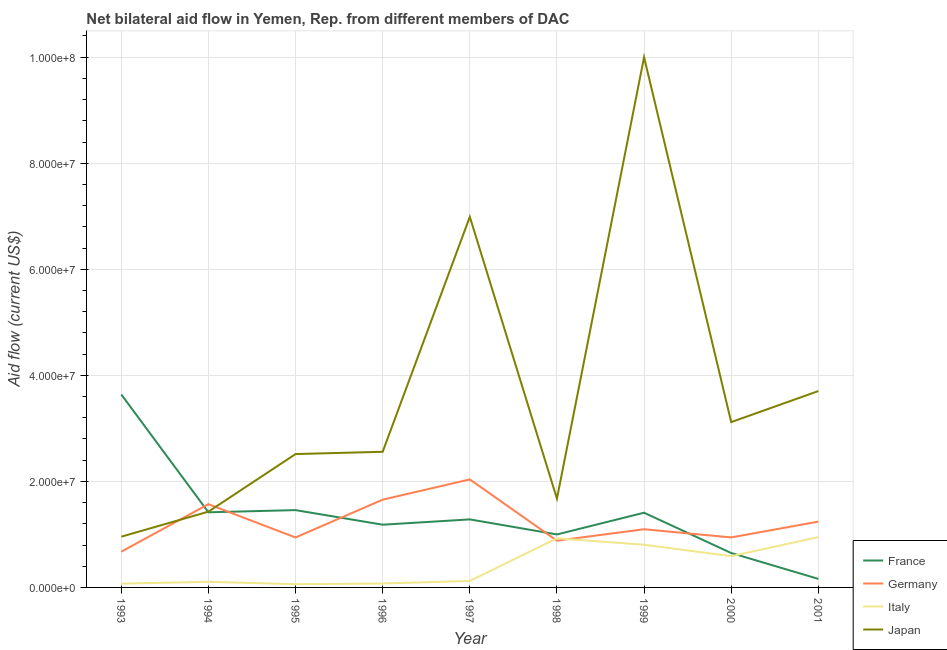Is the number of lines equal to the number of legend labels?
Your answer should be very brief. Yes. What is the amount of aid given by japan in 2000?
Provide a short and direct response. 3.12e+07. Across all years, what is the maximum amount of aid given by italy?
Your answer should be very brief. 9.49e+06. Across all years, what is the minimum amount of aid given by italy?
Provide a short and direct response. 6.10e+05. In which year was the amount of aid given by italy maximum?
Offer a very short reply. 2001. What is the total amount of aid given by germany in the graph?
Your answer should be compact. 1.10e+08. What is the difference between the amount of aid given by france in 1995 and that in 2001?
Your answer should be compact. 1.30e+07. What is the difference between the amount of aid given by germany in 2000 and the amount of aid given by japan in 1996?
Your answer should be compact. -1.62e+07. What is the average amount of aid given by japan per year?
Make the answer very short. 3.66e+07. In the year 1994, what is the difference between the amount of aid given by italy and amount of aid given by france?
Ensure brevity in your answer.  -1.31e+07. In how many years, is the amount of aid given by italy greater than 48000000 US$?
Your answer should be very brief. 0. What is the ratio of the amount of aid given by germany in 1994 to that in 1995?
Keep it short and to the point. 1.67. Is the difference between the amount of aid given by italy in 1997 and 2001 greater than the difference between the amount of aid given by japan in 1997 and 2001?
Your answer should be compact. No. What is the difference between the highest and the second highest amount of aid given by japan?
Your answer should be very brief. 3.01e+07. What is the difference between the highest and the lowest amount of aid given by japan?
Provide a short and direct response. 9.04e+07. Is the sum of the amount of aid given by germany in 1993 and 1997 greater than the maximum amount of aid given by italy across all years?
Ensure brevity in your answer.  Yes. Is it the case that in every year, the sum of the amount of aid given by france and amount of aid given by germany is greater than the sum of amount of aid given by italy and amount of aid given by japan?
Provide a short and direct response. No. Is it the case that in every year, the sum of the amount of aid given by france and amount of aid given by germany is greater than the amount of aid given by italy?
Give a very brief answer. Yes. How many lines are there?
Your answer should be compact. 4. Are the values on the major ticks of Y-axis written in scientific E-notation?
Your answer should be very brief. Yes. Does the graph contain grids?
Give a very brief answer. Yes. Where does the legend appear in the graph?
Your response must be concise. Bottom right. What is the title of the graph?
Keep it short and to the point. Net bilateral aid flow in Yemen, Rep. from different members of DAC. What is the Aid flow (current US$) of France in 1993?
Offer a very short reply. 3.64e+07. What is the Aid flow (current US$) of Germany in 1993?
Give a very brief answer. 6.74e+06. What is the Aid flow (current US$) in Italy in 1993?
Your answer should be compact. 7.10e+05. What is the Aid flow (current US$) of Japan in 1993?
Provide a succinct answer. 9.57e+06. What is the Aid flow (current US$) of France in 1994?
Your response must be concise. 1.42e+07. What is the Aid flow (current US$) in Germany in 1994?
Keep it short and to the point. 1.57e+07. What is the Aid flow (current US$) in Italy in 1994?
Offer a terse response. 1.06e+06. What is the Aid flow (current US$) of Japan in 1994?
Offer a very short reply. 1.43e+07. What is the Aid flow (current US$) of France in 1995?
Provide a short and direct response. 1.46e+07. What is the Aid flow (current US$) of Germany in 1995?
Keep it short and to the point. 9.42e+06. What is the Aid flow (current US$) of Italy in 1995?
Your answer should be very brief. 6.10e+05. What is the Aid flow (current US$) in Japan in 1995?
Offer a very short reply. 2.52e+07. What is the Aid flow (current US$) in France in 1996?
Offer a terse response. 1.18e+07. What is the Aid flow (current US$) in Germany in 1996?
Ensure brevity in your answer.  1.66e+07. What is the Aid flow (current US$) in Italy in 1996?
Give a very brief answer. 7.40e+05. What is the Aid flow (current US$) of Japan in 1996?
Give a very brief answer. 2.56e+07. What is the Aid flow (current US$) of France in 1997?
Give a very brief answer. 1.28e+07. What is the Aid flow (current US$) in Germany in 1997?
Keep it short and to the point. 2.04e+07. What is the Aid flow (current US$) in Italy in 1997?
Ensure brevity in your answer.  1.22e+06. What is the Aid flow (current US$) of Japan in 1997?
Offer a terse response. 6.99e+07. What is the Aid flow (current US$) of France in 1998?
Your answer should be very brief. 9.99e+06. What is the Aid flow (current US$) in Germany in 1998?
Your answer should be very brief. 8.82e+06. What is the Aid flow (current US$) of Italy in 1998?
Give a very brief answer. 9.26e+06. What is the Aid flow (current US$) in Japan in 1998?
Your answer should be very brief. 1.67e+07. What is the Aid flow (current US$) in France in 1999?
Your answer should be compact. 1.41e+07. What is the Aid flow (current US$) in Germany in 1999?
Provide a short and direct response. 1.10e+07. What is the Aid flow (current US$) of Italy in 1999?
Offer a terse response. 8.05e+06. What is the Aid flow (current US$) of Japan in 1999?
Provide a succinct answer. 1.00e+08. What is the Aid flow (current US$) in France in 2000?
Offer a terse response. 6.49e+06. What is the Aid flow (current US$) in Germany in 2000?
Keep it short and to the point. 9.43e+06. What is the Aid flow (current US$) in Italy in 2000?
Your answer should be compact. 5.89e+06. What is the Aid flow (current US$) of Japan in 2000?
Offer a terse response. 3.12e+07. What is the Aid flow (current US$) of France in 2001?
Make the answer very short. 1.61e+06. What is the Aid flow (current US$) of Germany in 2001?
Ensure brevity in your answer.  1.24e+07. What is the Aid flow (current US$) in Italy in 2001?
Ensure brevity in your answer.  9.49e+06. What is the Aid flow (current US$) of Japan in 2001?
Provide a succinct answer. 3.70e+07. Across all years, what is the maximum Aid flow (current US$) of France?
Provide a succinct answer. 3.64e+07. Across all years, what is the maximum Aid flow (current US$) of Germany?
Ensure brevity in your answer.  2.04e+07. Across all years, what is the maximum Aid flow (current US$) in Italy?
Your answer should be very brief. 9.49e+06. Across all years, what is the maximum Aid flow (current US$) in Japan?
Your answer should be compact. 1.00e+08. Across all years, what is the minimum Aid flow (current US$) of France?
Offer a terse response. 1.61e+06. Across all years, what is the minimum Aid flow (current US$) in Germany?
Your response must be concise. 6.74e+06. Across all years, what is the minimum Aid flow (current US$) of Italy?
Provide a succinct answer. 6.10e+05. Across all years, what is the minimum Aid flow (current US$) of Japan?
Offer a very short reply. 9.57e+06. What is the total Aid flow (current US$) of France in the graph?
Make the answer very short. 1.22e+08. What is the total Aid flow (current US$) in Germany in the graph?
Keep it short and to the point. 1.10e+08. What is the total Aid flow (current US$) of Italy in the graph?
Give a very brief answer. 3.70e+07. What is the total Aid flow (current US$) of Japan in the graph?
Keep it short and to the point. 3.29e+08. What is the difference between the Aid flow (current US$) in France in 1993 and that in 1994?
Provide a short and direct response. 2.22e+07. What is the difference between the Aid flow (current US$) of Germany in 1993 and that in 1994?
Make the answer very short. -8.96e+06. What is the difference between the Aid flow (current US$) of Italy in 1993 and that in 1994?
Keep it short and to the point. -3.50e+05. What is the difference between the Aid flow (current US$) in Japan in 1993 and that in 1994?
Provide a short and direct response. -4.72e+06. What is the difference between the Aid flow (current US$) in France in 1993 and that in 1995?
Keep it short and to the point. 2.18e+07. What is the difference between the Aid flow (current US$) in Germany in 1993 and that in 1995?
Your answer should be compact. -2.68e+06. What is the difference between the Aid flow (current US$) of Japan in 1993 and that in 1995?
Provide a succinct answer. -1.56e+07. What is the difference between the Aid flow (current US$) of France in 1993 and that in 1996?
Offer a very short reply. 2.46e+07. What is the difference between the Aid flow (current US$) of Germany in 1993 and that in 1996?
Make the answer very short. -9.81e+06. What is the difference between the Aid flow (current US$) in Japan in 1993 and that in 1996?
Provide a succinct answer. -1.60e+07. What is the difference between the Aid flow (current US$) in France in 1993 and that in 1997?
Your answer should be compact. 2.36e+07. What is the difference between the Aid flow (current US$) in Germany in 1993 and that in 1997?
Offer a very short reply. -1.36e+07. What is the difference between the Aid flow (current US$) in Italy in 1993 and that in 1997?
Keep it short and to the point. -5.10e+05. What is the difference between the Aid flow (current US$) of Japan in 1993 and that in 1997?
Your answer should be compact. -6.03e+07. What is the difference between the Aid flow (current US$) of France in 1993 and that in 1998?
Your response must be concise. 2.64e+07. What is the difference between the Aid flow (current US$) in Germany in 1993 and that in 1998?
Your answer should be compact. -2.08e+06. What is the difference between the Aid flow (current US$) of Italy in 1993 and that in 1998?
Your response must be concise. -8.55e+06. What is the difference between the Aid flow (current US$) in Japan in 1993 and that in 1998?
Your answer should be compact. -7.17e+06. What is the difference between the Aid flow (current US$) in France in 1993 and that in 1999?
Offer a terse response. 2.23e+07. What is the difference between the Aid flow (current US$) in Germany in 1993 and that in 1999?
Your response must be concise. -4.23e+06. What is the difference between the Aid flow (current US$) in Italy in 1993 and that in 1999?
Provide a succinct answer. -7.34e+06. What is the difference between the Aid flow (current US$) in Japan in 1993 and that in 1999?
Make the answer very short. -9.04e+07. What is the difference between the Aid flow (current US$) of France in 1993 and that in 2000?
Offer a very short reply. 2.99e+07. What is the difference between the Aid flow (current US$) of Germany in 1993 and that in 2000?
Give a very brief answer. -2.69e+06. What is the difference between the Aid flow (current US$) in Italy in 1993 and that in 2000?
Offer a terse response. -5.18e+06. What is the difference between the Aid flow (current US$) of Japan in 1993 and that in 2000?
Your response must be concise. -2.16e+07. What is the difference between the Aid flow (current US$) of France in 1993 and that in 2001?
Ensure brevity in your answer.  3.48e+07. What is the difference between the Aid flow (current US$) in Germany in 1993 and that in 2001?
Your answer should be compact. -5.67e+06. What is the difference between the Aid flow (current US$) in Italy in 1993 and that in 2001?
Keep it short and to the point. -8.78e+06. What is the difference between the Aid flow (current US$) in Japan in 1993 and that in 2001?
Your answer should be very brief. -2.75e+07. What is the difference between the Aid flow (current US$) in France in 1994 and that in 1995?
Provide a short and direct response. -4.10e+05. What is the difference between the Aid flow (current US$) in Germany in 1994 and that in 1995?
Your answer should be very brief. 6.28e+06. What is the difference between the Aid flow (current US$) of Italy in 1994 and that in 1995?
Make the answer very short. 4.50e+05. What is the difference between the Aid flow (current US$) of Japan in 1994 and that in 1995?
Keep it short and to the point. -1.09e+07. What is the difference between the Aid flow (current US$) of France in 1994 and that in 1996?
Provide a short and direct response. 2.34e+06. What is the difference between the Aid flow (current US$) of Germany in 1994 and that in 1996?
Offer a terse response. -8.50e+05. What is the difference between the Aid flow (current US$) of Italy in 1994 and that in 1996?
Your response must be concise. 3.20e+05. What is the difference between the Aid flow (current US$) in Japan in 1994 and that in 1996?
Your response must be concise. -1.13e+07. What is the difference between the Aid flow (current US$) of France in 1994 and that in 1997?
Offer a very short reply. 1.34e+06. What is the difference between the Aid flow (current US$) in Germany in 1994 and that in 1997?
Your answer should be compact. -4.67e+06. What is the difference between the Aid flow (current US$) of Italy in 1994 and that in 1997?
Give a very brief answer. -1.60e+05. What is the difference between the Aid flow (current US$) in Japan in 1994 and that in 1997?
Your answer should be very brief. -5.56e+07. What is the difference between the Aid flow (current US$) of France in 1994 and that in 1998?
Your answer should be compact. 4.18e+06. What is the difference between the Aid flow (current US$) of Germany in 1994 and that in 1998?
Offer a terse response. 6.88e+06. What is the difference between the Aid flow (current US$) in Italy in 1994 and that in 1998?
Offer a terse response. -8.20e+06. What is the difference between the Aid flow (current US$) of Japan in 1994 and that in 1998?
Make the answer very short. -2.45e+06. What is the difference between the Aid flow (current US$) of Germany in 1994 and that in 1999?
Keep it short and to the point. 4.73e+06. What is the difference between the Aid flow (current US$) of Italy in 1994 and that in 1999?
Keep it short and to the point. -6.99e+06. What is the difference between the Aid flow (current US$) of Japan in 1994 and that in 1999?
Give a very brief answer. -8.57e+07. What is the difference between the Aid flow (current US$) of France in 1994 and that in 2000?
Your answer should be compact. 7.68e+06. What is the difference between the Aid flow (current US$) in Germany in 1994 and that in 2000?
Provide a short and direct response. 6.27e+06. What is the difference between the Aid flow (current US$) of Italy in 1994 and that in 2000?
Keep it short and to the point. -4.83e+06. What is the difference between the Aid flow (current US$) in Japan in 1994 and that in 2000?
Your response must be concise. -1.69e+07. What is the difference between the Aid flow (current US$) of France in 1994 and that in 2001?
Your response must be concise. 1.26e+07. What is the difference between the Aid flow (current US$) in Germany in 1994 and that in 2001?
Ensure brevity in your answer.  3.29e+06. What is the difference between the Aid flow (current US$) in Italy in 1994 and that in 2001?
Your response must be concise. -8.43e+06. What is the difference between the Aid flow (current US$) of Japan in 1994 and that in 2001?
Your answer should be compact. -2.27e+07. What is the difference between the Aid flow (current US$) of France in 1995 and that in 1996?
Give a very brief answer. 2.75e+06. What is the difference between the Aid flow (current US$) in Germany in 1995 and that in 1996?
Your answer should be compact. -7.13e+06. What is the difference between the Aid flow (current US$) in Italy in 1995 and that in 1996?
Keep it short and to the point. -1.30e+05. What is the difference between the Aid flow (current US$) in Japan in 1995 and that in 1996?
Offer a very short reply. -4.30e+05. What is the difference between the Aid flow (current US$) of France in 1995 and that in 1997?
Offer a very short reply. 1.75e+06. What is the difference between the Aid flow (current US$) of Germany in 1995 and that in 1997?
Your response must be concise. -1.10e+07. What is the difference between the Aid flow (current US$) in Italy in 1995 and that in 1997?
Provide a short and direct response. -6.10e+05. What is the difference between the Aid flow (current US$) of Japan in 1995 and that in 1997?
Give a very brief answer. -4.47e+07. What is the difference between the Aid flow (current US$) of France in 1995 and that in 1998?
Provide a short and direct response. 4.59e+06. What is the difference between the Aid flow (current US$) of Germany in 1995 and that in 1998?
Provide a short and direct response. 6.00e+05. What is the difference between the Aid flow (current US$) of Italy in 1995 and that in 1998?
Make the answer very short. -8.65e+06. What is the difference between the Aid flow (current US$) in Japan in 1995 and that in 1998?
Offer a terse response. 8.41e+06. What is the difference between the Aid flow (current US$) in Germany in 1995 and that in 1999?
Give a very brief answer. -1.55e+06. What is the difference between the Aid flow (current US$) in Italy in 1995 and that in 1999?
Your answer should be very brief. -7.44e+06. What is the difference between the Aid flow (current US$) of Japan in 1995 and that in 1999?
Your response must be concise. -7.48e+07. What is the difference between the Aid flow (current US$) in France in 1995 and that in 2000?
Offer a terse response. 8.09e+06. What is the difference between the Aid flow (current US$) in Italy in 1995 and that in 2000?
Keep it short and to the point. -5.28e+06. What is the difference between the Aid flow (current US$) of Japan in 1995 and that in 2000?
Keep it short and to the point. -6.03e+06. What is the difference between the Aid flow (current US$) in France in 1995 and that in 2001?
Your answer should be very brief. 1.30e+07. What is the difference between the Aid flow (current US$) of Germany in 1995 and that in 2001?
Give a very brief answer. -2.99e+06. What is the difference between the Aid flow (current US$) in Italy in 1995 and that in 2001?
Offer a very short reply. -8.88e+06. What is the difference between the Aid flow (current US$) of Japan in 1995 and that in 2001?
Provide a succinct answer. -1.19e+07. What is the difference between the Aid flow (current US$) in Germany in 1996 and that in 1997?
Your response must be concise. -3.82e+06. What is the difference between the Aid flow (current US$) in Italy in 1996 and that in 1997?
Provide a short and direct response. -4.80e+05. What is the difference between the Aid flow (current US$) of Japan in 1996 and that in 1997?
Keep it short and to the point. -4.43e+07. What is the difference between the Aid flow (current US$) in France in 1996 and that in 1998?
Your response must be concise. 1.84e+06. What is the difference between the Aid flow (current US$) of Germany in 1996 and that in 1998?
Make the answer very short. 7.73e+06. What is the difference between the Aid flow (current US$) in Italy in 1996 and that in 1998?
Your response must be concise. -8.52e+06. What is the difference between the Aid flow (current US$) of Japan in 1996 and that in 1998?
Give a very brief answer. 8.84e+06. What is the difference between the Aid flow (current US$) in France in 1996 and that in 1999?
Offer a terse response. -2.26e+06. What is the difference between the Aid flow (current US$) in Germany in 1996 and that in 1999?
Make the answer very short. 5.58e+06. What is the difference between the Aid flow (current US$) in Italy in 1996 and that in 1999?
Provide a short and direct response. -7.31e+06. What is the difference between the Aid flow (current US$) of Japan in 1996 and that in 1999?
Provide a succinct answer. -7.44e+07. What is the difference between the Aid flow (current US$) of France in 1996 and that in 2000?
Offer a very short reply. 5.34e+06. What is the difference between the Aid flow (current US$) in Germany in 1996 and that in 2000?
Make the answer very short. 7.12e+06. What is the difference between the Aid flow (current US$) of Italy in 1996 and that in 2000?
Your answer should be compact. -5.15e+06. What is the difference between the Aid flow (current US$) in Japan in 1996 and that in 2000?
Your answer should be very brief. -5.60e+06. What is the difference between the Aid flow (current US$) of France in 1996 and that in 2001?
Provide a short and direct response. 1.02e+07. What is the difference between the Aid flow (current US$) of Germany in 1996 and that in 2001?
Ensure brevity in your answer.  4.14e+06. What is the difference between the Aid flow (current US$) of Italy in 1996 and that in 2001?
Provide a succinct answer. -8.75e+06. What is the difference between the Aid flow (current US$) in Japan in 1996 and that in 2001?
Ensure brevity in your answer.  -1.14e+07. What is the difference between the Aid flow (current US$) in France in 1997 and that in 1998?
Keep it short and to the point. 2.84e+06. What is the difference between the Aid flow (current US$) in Germany in 1997 and that in 1998?
Provide a short and direct response. 1.16e+07. What is the difference between the Aid flow (current US$) of Italy in 1997 and that in 1998?
Offer a very short reply. -8.04e+06. What is the difference between the Aid flow (current US$) of Japan in 1997 and that in 1998?
Make the answer very short. 5.32e+07. What is the difference between the Aid flow (current US$) in France in 1997 and that in 1999?
Keep it short and to the point. -1.26e+06. What is the difference between the Aid flow (current US$) of Germany in 1997 and that in 1999?
Your answer should be compact. 9.40e+06. What is the difference between the Aid flow (current US$) in Italy in 1997 and that in 1999?
Your response must be concise. -6.83e+06. What is the difference between the Aid flow (current US$) in Japan in 1997 and that in 1999?
Provide a succinct answer. -3.01e+07. What is the difference between the Aid flow (current US$) in France in 1997 and that in 2000?
Keep it short and to the point. 6.34e+06. What is the difference between the Aid flow (current US$) in Germany in 1997 and that in 2000?
Your response must be concise. 1.09e+07. What is the difference between the Aid flow (current US$) in Italy in 1997 and that in 2000?
Ensure brevity in your answer.  -4.67e+06. What is the difference between the Aid flow (current US$) of Japan in 1997 and that in 2000?
Your answer should be compact. 3.87e+07. What is the difference between the Aid flow (current US$) in France in 1997 and that in 2001?
Offer a terse response. 1.12e+07. What is the difference between the Aid flow (current US$) of Germany in 1997 and that in 2001?
Provide a succinct answer. 7.96e+06. What is the difference between the Aid flow (current US$) of Italy in 1997 and that in 2001?
Your answer should be very brief. -8.27e+06. What is the difference between the Aid flow (current US$) of Japan in 1997 and that in 2001?
Provide a short and direct response. 3.29e+07. What is the difference between the Aid flow (current US$) in France in 1998 and that in 1999?
Keep it short and to the point. -4.10e+06. What is the difference between the Aid flow (current US$) of Germany in 1998 and that in 1999?
Offer a terse response. -2.15e+06. What is the difference between the Aid flow (current US$) in Italy in 1998 and that in 1999?
Give a very brief answer. 1.21e+06. What is the difference between the Aid flow (current US$) in Japan in 1998 and that in 1999?
Your answer should be compact. -8.33e+07. What is the difference between the Aid flow (current US$) in France in 1998 and that in 2000?
Provide a short and direct response. 3.50e+06. What is the difference between the Aid flow (current US$) in Germany in 1998 and that in 2000?
Your answer should be very brief. -6.10e+05. What is the difference between the Aid flow (current US$) in Italy in 1998 and that in 2000?
Offer a very short reply. 3.37e+06. What is the difference between the Aid flow (current US$) in Japan in 1998 and that in 2000?
Ensure brevity in your answer.  -1.44e+07. What is the difference between the Aid flow (current US$) of France in 1998 and that in 2001?
Give a very brief answer. 8.38e+06. What is the difference between the Aid flow (current US$) in Germany in 1998 and that in 2001?
Give a very brief answer. -3.59e+06. What is the difference between the Aid flow (current US$) of Japan in 1998 and that in 2001?
Offer a terse response. -2.03e+07. What is the difference between the Aid flow (current US$) of France in 1999 and that in 2000?
Your answer should be very brief. 7.60e+06. What is the difference between the Aid flow (current US$) in Germany in 1999 and that in 2000?
Offer a very short reply. 1.54e+06. What is the difference between the Aid flow (current US$) of Italy in 1999 and that in 2000?
Your response must be concise. 2.16e+06. What is the difference between the Aid flow (current US$) of Japan in 1999 and that in 2000?
Give a very brief answer. 6.88e+07. What is the difference between the Aid flow (current US$) of France in 1999 and that in 2001?
Offer a very short reply. 1.25e+07. What is the difference between the Aid flow (current US$) of Germany in 1999 and that in 2001?
Your answer should be very brief. -1.44e+06. What is the difference between the Aid flow (current US$) in Italy in 1999 and that in 2001?
Keep it short and to the point. -1.44e+06. What is the difference between the Aid flow (current US$) of Japan in 1999 and that in 2001?
Keep it short and to the point. 6.30e+07. What is the difference between the Aid flow (current US$) of France in 2000 and that in 2001?
Provide a succinct answer. 4.88e+06. What is the difference between the Aid flow (current US$) of Germany in 2000 and that in 2001?
Ensure brevity in your answer.  -2.98e+06. What is the difference between the Aid flow (current US$) of Italy in 2000 and that in 2001?
Provide a succinct answer. -3.60e+06. What is the difference between the Aid flow (current US$) in Japan in 2000 and that in 2001?
Your answer should be very brief. -5.85e+06. What is the difference between the Aid flow (current US$) in France in 1993 and the Aid flow (current US$) in Germany in 1994?
Your answer should be very brief. 2.07e+07. What is the difference between the Aid flow (current US$) in France in 1993 and the Aid flow (current US$) in Italy in 1994?
Make the answer very short. 3.53e+07. What is the difference between the Aid flow (current US$) in France in 1993 and the Aid flow (current US$) in Japan in 1994?
Provide a short and direct response. 2.21e+07. What is the difference between the Aid flow (current US$) of Germany in 1993 and the Aid flow (current US$) of Italy in 1994?
Make the answer very short. 5.68e+06. What is the difference between the Aid flow (current US$) of Germany in 1993 and the Aid flow (current US$) of Japan in 1994?
Give a very brief answer. -7.55e+06. What is the difference between the Aid flow (current US$) of Italy in 1993 and the Aid flow (current US$) of Japan in 1994?
Your response must be concise. -1.36e+07. What is the difference between the Aid flow (current US$) of France in 1993 and the Aid flow (current US$) of Germany in 1995?
Your answer should be compact. 2.70e+07. What is the difference between the Aid flow (current US$) of France in 1993 and the Aid flow (current US$) of Italy in 1995?
Your answer should be compact. 3.58e+07. What is the difference between the Aid flow (current US$) of France in 1993 and the Aid flow (current US$) of Japan in 1995?
Your answer should be very brief. 1.12e+07. What is the difference between the Aid flow (current US$) of Germany in 1993 and the Aid flow (current US$) of Italy in 1995?
Offer a very short reply. 6.13e+06. What is the difference between the Aid flow (current US$) of Germany in 1993 and the Aid flow (current US$) of Japan in 1995?
Your answer should be very brief. -1.84e+07. What is the difference between the Aid flow (current US$) in Italy in 1993 and the Aid flow (current US$) in Japan in 1995?
Your response must be concise. -2.44e+07. What is the difference between the Aid flow (current US$) in France in 1993 and the Aid flow (current US$) in Germany in 1996?
Ensure brevity in your answer.  1.98e+07. What is the difference between the Aid flow (current US$) of France in 1993 and the Aid flow (current US$) of Italy in 1996?
Your answer should be very brief. 3.56e+07. What is the difference between the Aid flow (current US$) of France in 1993 and the Aid flow (current US$) of Japan in 1996?
Your answer should be very brief. 1.08e+07. What is the difference between the Aid flow (current US$) in Germany in 1993 and the Aid flow (current US$) in Italy in 1996?
Provide a short and direct response. 6.00e+06. What is the difference between the Aid flow (current US$) of Germany in 1993 and the Aid flow (current US$) of Japan in 1996?
Provide a short and direct response. -1.88e+07. What is the difference between the Aid flow (current US$) in Italy in 1993 and the Aid flow (current US$) in Japan in 1996?
Provide a short and direct response. -2.49e+07. What is the difference between the Aid flow (current US$) in France in 1993 and the Aid flow (current US$) in Germany in 1997?
Keep it short and to the point. 1.60e+07. What is the difference between the Aid flow (current US$) of France in 1993 and the Aid flow (current US$) of Italy in 1997?
Offer a terse response. 3.52e+07. What is the difference between the Aid flow (current US$) of France in 1993 and the Aid flow (current US$) of Japan in 1997?
Offer a terse response. -3.35e+07. What is the difference between the Aid flow (current US$) in Germany in 1993 and the Aid flow (current US$) in Italy in 1997?
Keep it short and to the point. 5.52e+06. What is the difference between the Aid flow (current US$) of Germany in 1993 and the Aid flow (current US$) of Japan in 1997?
Ensure brevity in your answer.  -6.32e+07. What is the difference between the Aid flow (current US$) in Italy in 1993 and the Aid flow (current US$) in Japan in 1997?
Give a very brief answer. -6.92e+07. What is the difference between the Aid flow (current US$) of France in 1993 and the Aid flow (current US$) of Germany in 1998?
Offer a very short reply. 2.76e+07. What is the difference between the Aid flow (current US$) of France in 1993 and the Aid flow (current US$) of Italy in 1998?
Your response must be concise. 2.71e+07. What is the difference between the Aid flow (current US$) in France in 1993 and the Aid flow (current US$) in Japan in 1998?
Provide a succinct answer. 1.96e+07. What is the difference between the Aid flow (current US$) in Germany in 1993 and the Aid flow (current US$) in Italy in 1998?
Provide a succinct answer. -2.52e+06. What is the difference between the Aid flow (current US$) in Germany in 1993 and the Aid flow (current US$) in Japan in 1998?
Make the answer very short. -1.00e+07. What is the difference between the Aid flow (current US$) in Italy in 1993 and the Aid flow (current US$) in Japan in 1998?
Provide a short and direct response. -1.60e+07. What is the difference between the Aid flow (current US$) of France in 1993 and the Aid flow (current US$) of Germany in 1999?
Offer a very short reply. 2.54e+07. What is the difference between the Aid flow (current US$) in France in 1993 and the Aid flow (current US$) in Italy in 1999?
Give a very brief answer. 2.83e+07. What is the difference between the Aid flow (current US$) of France in 1993 and the Aid flow (current US$) of Japan in 1999?
Provide a short and direct response. -6.36e+07. What is the difference between the Aid flow (current US$) in Germany in 1993 and the Aid flow (current US$) in Italy in 1999?
Make the answer very short. -1.31e+06. What is the difference between the Aid flow (current US$) of Germany in 1993 and the Aid flow (current US$) of Japan in 1999?
Offer a terse response. -9.33e+07. What is the difference between the Aid flow (current US$) of Italy in 1993 and the Aid flow (current US$) of Japan in 1999?
Your answer should be very brief. -9.93e+07. What is the difference between the Aid flow (current US$) in France in 1993 and the Aid flow (current US$) in Germany in 2000?
Offer a terse response. 2.70e+07. What is the difference between the Aid flow (current US$) of France in 1993 and the Aid flow (current US$) of Italy in 2000?
Your answer should be very brief. 3.05e+07. What is the difference between the Aid flow (current US$) in France in 1993 and the Aid flow (current US$) in Japan in 2000?
Ensure brevity in your answer.  5.21e+06. What is the difference between the Aid flow (current US$) of Germany in 1993 and the Aid flow (current US$) of Italy in 2000?
Your answer should be compact. 8.50e+05. What is the difference between the Aid flow (current US$) of Germany in 1993 and the Aid flow (current US$) of Japan in 2000?
Provide a succinct answer. -2.44e+07. What is the difference between the Aid flow (current US$) in Italy in 1993 and the Aid flow (current US$) in Japan in 2000?
Provide a short and direct response. -3.05e+07. What is the difference between the Aid flow (current US$) of France in 1993 and the Aid flow (current US$) of Germany in 2001?
Give a very brief answer. 2.40e+07. What is the difference between the Aid flow (current US$) of France in 1993 and the Aid flow (current US$) of Italy in 2001?
Provide a short and direct response. 2.69e+07. What is the difference between the Aid flow (current US$) of France in 1993 and the Aid flow (current US$) of Japan in 2001?
Your response must be concise. -6.40e+05. What is the difference between the Aid flow (current US$) in Germany in 1993 and the Aid flow (current US$) in Italy in 2001?
Your answer should be compact. -2.75e+06. What is the difference between the Aid flow (current US$) of Germany in 1993 and the Aid flow (current US$) of Japan in 2001?
Provide a succinct answer. -3.03e+07. What is the difference between the Aid flow (current US$) of Italy in 1993 and the Aid flow (current US$) of Japan in 2001?
Provide a succinct answer. -3.63e+07. What is the difference between the Aid flow (current US$) in France in 1994 and the Aid flow (current US$) in Germany in 1995?
Your response must be concise. 4.75e+06. What is the difference between the Aid flow (current US$) in France in 1994 and the Aid flow (current US$) in Italy in 1995?
Provide a succinct answer. 1.36e+07. What is the difference between the Aid flow (current US$) in France in 1994 and the Aid flow (current US$) in Japan in 1995?
Make the answer very short. -1.10e+07. What is the difference between the Aid flow (current US$) in Germany in 1994 and the Aid flow (current US$) in Italy in 1995?
Your answer should be compact. 1.51e+07. What is the difference between the Aid flow (current US$) of Germany in 1994 and the Aid flow (current US$) of Japan in 1995?
Provide a succinct answer. -9.45e+06. What is the difference between the Aid flow (current US$) of Italy in 1994 and the Aid flow (current US$) of Japan in 1995?
Give a very brief answer. -2.41e+07. What is the difference between the Aid flow (current US$) of France in 1994 and the Aid flow (current US$) of Germany in 1996?
Provide a succinct answer. -2.38e+06. What is the difference between the Aid flow (current US$) in France in 1994 and the Aid flow (current US$) in Italy in 1996?
Keep it short and to the point. 1.34e+07. What is the difference between the Aid flow (current US$) in France in 1994 and the Aid flow (current US$) in Japan in 1996?
Offer a very short reply. -1.14e+07. What is the difference between the Aid flow (current US$) of Germany in 1994 and the Aid flow (current US$) of Italy in 1996?
Make the answer very short. 1.50e+07. What is the difference between the Aid flow (current US$) of Germany in 1994 and the Aid flow (current US$) of Japan in 1996?
Offer a very short reply. -9.88e+06. What is the difference between the Aid flow (current US$) in Italy in 1994 and the Aid flow (current US$) in Japan in 1996?
Offer a very short reply. -2.45e+07. What is the difference between the Aid flow (current US$) of France in 1994 and the Aid flow (current US$) of Germany in 1997?
Offer a terse response. -6.20e+06. What is the difference between the Aid flow (current US$) of France in 1994 and the Aid flow (current US$) of Italy in 1997?
Your answer should be very brief. 1.30e+07. What is the difference between the Aid flow (current US$) of France in 1994 and the Aid flow (current US$) of Japan in 1997?
Give a very brief answer. -5.57e+07. What is the difference between the Aid flow (current US$) in Germany in 1994 and the Aid flow (current US$) in Italy in 1997?
Your response must be concise. 1.45e+07. What is the difference between the Aid flow (current US$) in Germany in 1994 and the Aid flow (current US$) in Japan in 1997?
Offer a very short reply. -5.42e+07. What is the difference between the Aid flow (current US$) in Italy in 1994 and the Aid flow (current US$) in Japan in 1997?
Provide a short and direct response. -6.88e+07. What is the difference between the Aid flow (current US$) in France in 1994 and the Aid flow (current US$) in Germany in 1998?
Your answer should be compact. 5.35e+06. What is the difference between the Aid flow (current US$) in France in 1994 and the Aid flow (current US$) in Italy in 1998?
Ensure brevity in your answer.  4.91e+06. What is the difference between the Aid flow (current US$) of France in 1994 and the Aid flow (current US$) of Japan in 1998?
Your answer should be very brief. -2.57e+06. What is the difference between the Aid flow (current US$) of Germany in 1994 and the Aid flow (current US$) of Italy in 1998?
Make the answer very short. 6.44e+06. What is the difference between the Aid flow (current US$) of Germany in 1994 and the Aid flow (current US$) of Japan in 1998?
Your response must be concise. -1.04e+06. What is the difference between the Aid flow (current US$) of Italy in 1994 and the Aid flow (current US$) of Japan in 1998?
Provide a short and direct response. -1.57e+07. What is the difference between the Aid flow (current US$) in France in 1994 and the Aid flow (current US$) in Germany in 1999?
Make the answer very short. 3.20e+06. What is the difference between the Aid flow (current US$) in France in 1994 and the Aid flow (current US$) in Italy in 1999?
Your response must be concise. 6.12e+06. What is the difference between the Aid flow (current US$) in France in 1994 and the Aid flow (current US$) in Japan in 1999?
Your response must be concise. -8.58e+07. What is the difference between the Aid flow (current US$) of Germany in 1994 and the Aid flow (current US$) of Italy in 1999?
Give a very brief answer. 7.65e+06. What is the difference between the Aid flow (current US$) in Germany in 1994 and the Aid flow (current US$) in Japan in 1999?
Keep it short and to the point. -8.43e+07. What is the difference between the Aid flow (current US$) of Italy in 1994 and the Aid flow (current US$) of Japan in 1999?
Make the answer very short. -9.89e+07. What is the difference between the Aid flow (current US$) of France in 1994 and the Aid flow (current US$) of Germany in 2000?
Ensure brevity in your answer.  4.74e+06. What is the difference between the Aid flow (current US$) in France in 1994 and the Aid flow (current US$) in Italy in 2000?
Offer a very short reply. 8.28e+06. What is the difference between the Aid flow (current US$) of France in 1994 and the Aid flow (current US$) of Japan in 2000?
Provide a short and direct response. -1.70e+07. What is the difference between the Aid flow (current US$) in Germany in 1994 and the Aid flow (current US$) in Italy in 2000?
Make the answer very short. 9.81e+06. What is the difference between the Aid flow (current US$) of Germany in 1994 and the Aid flow (current US$) of Japan in 2000?
Give a very brief answer. -1.55e+07. What is the difference between the Aid flow (current US$) of Italy in 1994 and the Aid flow (current US$) of Japan in 2000?
Ensure brevity in your answer.  -3.01e+07. What is the difference between the Aid flow (current US$) in France in 1994 and the Aid flow (current US$) in Germany in 2001?
Keep it short and to the point. 1.76e+06. What is the difference between the Aid flow (current US$) in France in 1994 and the Aid flow (current US$) in Italy in 2001?
Give a very brief answer. 4.68e+06. What is the difference between the Aid flow (current US$) of France in 1994 and the Aid flow (current US$) of Japan in 2001?
Keep it short and to the point. -2.29e+07. What is the difference between the Aid flow (current US$) in Germany in 1994 and the Aid flow (current US$) in Italy in 2001?
Make the answer very short. 6.21e+06. What is the difference between the Aid flow (current US$) in Germany in 1994 and the Aid flow (current US$) in Japan in 2001?
Keep it short and to the point. -2.13e+07. What is the difference between the Aid flow (current US$) of Italy in 1994 and the Aid flow (current US$) of Japan in 2001?
Provide a short and direct response. -3.60e+07. What is the difference between the Aid flow (current US$) of France in 1995 and the Aid flow (current US$) of Germany in 1996?
Make the answer very short. -1.97e+06. What is the difference between the Aid flow (current US$) in France in 1995 and the Aid flow (current US$) in Italy in 1996?
Provide a succinct answer. 1.38e+07. What is the difference between the Aid flow (current US$) of France in 1995 and the Aid flow (current US$) of Japan in 1996?
Ensure brevity in your answer.  -1.10e+07. What is the difference between the Aid flow (current US$) in Germany in 1995 and the Aid flow (current US$) in Italy in 1996?
Ensure brevity in your answer.  8.68e+06. What is the difference between the Aid flow (current US$) in Germany in 1995 and the Aid flow (current US$) in Japan in 1996?
Ensure brevity in your answer.  -1.62e+07. What is the difference between the Aid flow (current US$) in Italy in 1995 and the Aid flow (current US$) in Japan in 1996?
Give a very brief answer. -2.50e+07. What is the difference between the Aid flow (current US$) in France in 1995 and the Aid flow (current US$) in Germany in 1997?
Offer a terse response. -5.79e+06. What is the difference between the Aid flow (current US$) of France in 1995 and the Aid flow (current US$) of Italy in 1997?
Keep it short and to the point. 1.34e+07. What is the difference between the Aid flow (current US$) in France in 1995 and the Aid flow (current US$) in Japan in 1997?
Your answer should be very brief. -5.53e+07. What is the difference between the Aid flow (current US$) of Germany in 1995 and the Aid flow (current US$) of Italy in 1997?
Give a very brief answer. 8.20e+06. What is the difference between the Aid flow (current US$) in Germany in 1995 and the Aid flow (current US$) in Japan in 1997?
Make the answer very short. -6.05e+07. What is the difference between the Aid flow (current US$) of Italy in 1995 and the Aid flow (current US$) of Japan in 1997?
Offer a very short reply. -6.93e+07. What is the difference between the Aid flow (current US$) in France in 1995 and the Aid flow (current US$) in Germany in 1998?
Give a very brief answer. 5.76e+06. What is the difference between the Aid flow (current US$) of France in 1995 and the Aid flow (current US$) of Italy in 1998?
Your answer should be very brief. 5.32e+06. What is the difference between the Aid flow (current US$) in France in 1995 and the Aid flow (current US$) in Japan in 1998?
Offer a very short reply. -2.16e+06. What is the difference between the Aid flow (current US$) in Germany in 1995 and the Aid flow (current US$) in Italy in 1998?
Your response must be concise. 1.60e+05. What is the difference between the Aid flow (current US$) in Germany in 1995 and the Aid flow (current US$) in Japan in 1998?
Offer a very short reply. -7.32e+06. What is the difference between the Aid flow (current US$) in Italy in 1995 and the Aid flow (current US$) in Japan in 1998?
Ensure brevity in your answer.  -1.61e+07. What is the difference between the Aid flow (current US$) in France in 1995 and the Aid flow (current US$) in Germany in 1999?
Your response must be concise. 3.61e+06. What is the difference between the Aid flow (current US$) in France in 1995 and the Aid flow (current US$) in Italy in 1999?
Your response must be concise. 6.53e+06. What is the difference between the Aid flow (current US$) in France in 1995 and the Aid flow (current US$) in Japan in 1999?
Your answer should be compact. -8.54e+07. What is the difference between the Aid flow (current US$) in Germany in 1995 and the Aid flow (current US$) in Italy in 1999?
Ensure brevity in your answer.  1.37e+06. What is the difference between the Aid flow (current US$) in Germany in 1995 and the Aid flow (current US$) in Japan in 1999?
Offer a terse response. -9.06e+07. What is the difference between the Aid flow (current US$) of Italy in 1995 and the Aid flow (current US$) of Japan in 1999?
Make the answer very short. -9.94e+07. What is the difference between the Aid flow (current US$) of France in 1995 and the Aid flow (current US$) of Germany in 2000?
Keep it short and to the point. 5.15e+06. What is the difference between the Aid flow (current US$) of France in 1995 and the Aid flow (current US$) of Italy in 2000?
Your response must be concise. 8.69e+06. What is the difference between the Aid flow (current US$) of France in 1995 and the Aid flow (current US$) of Japan in 2000?
Offer a very short reply. -1.66e+07. What is the difference between the Aid flow (current US$) in Germany in 1995 and the Aid flow (current US$) in Italy in 2000?
Ensure brevity in your answer.  3.53e+06. What is the difference between the Aid flow (current US$) in Germany in 1995 and the Aid flow (current US$) in Japan in 2000?
Provide a short and direct response. -2.18e+07. What is the difference between the Aid flow (current US$) in Italy in 1995 and the Aid flow (current US$) in Japan in 2000?
Keep it short and to the point. -3.06e+07. What is the difference between the Aid flow (current US$) of France in 1995 and the Aid flow (current US$) of Germany in 2001?
Your answer should be compact. 2.17e+06. What is the difference between the Aid flow (current US$) of France in 1995 and the Aid flow (current US$) of Italy in 2001?
Provide a short and direct response. 5.09e+06. What is the difference between the Aid flow (current US$) in France in 1995 and the Aid flow (current US$) in Japan in 2001?
Provide a succinct answer. -2.24e+07. What is the difference between the Aid flow (current US$) of Germany in 1995 and the Aid flow (current US$) of Italy in 2001?
Provide a short and direct response. -7.00e+04. What is the difference between the Aid flow (current US$) in Germany in 1995 and the Aid flow (current US$) in Japan in 2001?
Offer a very short reply. -2.76e+07. What is the difference between the Aid flow (current US$) of Italy in 1995 and the Aid flow (current US$) of Japan in 2001?
Your answer should be compact. -3.64e+07. What is the difference between the Aid flow (current US$) in France in 1996 and the Aid flow (current US$) in Germany in 1997?
Your answer should be very brief. -8.54e+06. What is the difference between the Aid flow (current US$) of France in 1996 and the Aid flow (current US$) of Italy in 1997?
Offer a very short reply. 1.06e+07. What is the difference between the Aid flow (current US$) of France in 1996 and the Aid flow (current US$) of Japan in 1997?
Your response must be concise. -5.81e+07. What is the difference between the Aid flow (current US$) in Germany in 1996 and the Aid flow (current US$) in Italy in 1997?
Give a very brief answer. 1.53e+07. What is the difference between the Aid flow (current US$) in Germany in 1996 and the Aid flow (current US$) in Japan in 1997?
Provide a succinct answer. -5.33e+07. What is the difference between the Aid flow (current US$) of Italy in 1996 and the Aid flow (current US$) of Japan in 1997?
Ensure brevity in your answer.  -6.92e+07. What is the difference between the Aid flow (current US$) in France in 1996 and the Aid flow (current US$) in Germany in 1998?
Ensure brevity in your answer.  3.01e+06. What is the difference between the Aid flow (current US$) of France in 1996 and the Aid flow (current US$) of Italy in 1998?
Your response must be concise. 2.57e+06. What is the difference between the Aid flow (current US$) in France in 1996 and the Aid flow (current US$) in Japan in 1998?
Your response must be concise. -4.91e+06. What is the difference between the Aid flow (current US$) of Germany in 1996 and the Aid flow (current US$) of Italy in 1998?
Make the answer very short. 7.29e+06. What is the difference between the Aid flow (current US$) of Germany in 1996 and the Aid flow (current US$) of Japan in 1998?
Provide a succinct answer. -1.90e+05. What is the difference between the Aid flow (current US$) in Italy in 1996 and the Aid flow (current US$) in Japan in 1998?
Provide a short and direct response. -1.60e+07. What is the difference between the Aid flow (current US$) of France in 1996 and the Aid flow (current US$) of Germany in 1999?
Provide a short and direct response. 8.60e+05. What is the difference between the Aid flow (current US$) in France in 1996 and the Aid flow (current US$) in Italy in 1999?
Ensure brevity in your answer.  3.78e+06. What is the difference between the Aid flow (current US$) of France in 1996 and the Aid flow (current US$) of Japan in 1999?
Ensure brevity in your answer.  -8.82e+07. What is the difference between the Aid flow (current US$) of Germany in 1996 and the Aid flow (current US$) of Italy in 1999?
Offer a terse response. 8.50e+06. What is the difference between the Aid flow (current US$) in Germany in 1996 and the Aid flow (current US$) in Japan in 1999?
Your response must be concise. -8.34e+07. What is the difference between the Aid flow (current US$) in Italy in 1996 and the Aid flow (current US$) in Japan in 1999?
Keep it short and to the point. -9.93e+07. What is the difference between the Aid flow (current US$) in France in 1996 and the Aid flow (current US$) in Germany in 2000?
Your answer should be very brief. 2.40e+06. What is the difference between the Aid flow (current US$) of France in 1996 and the Aid flow (current US$) of Italy in 2000?
Offer a very short reply. 5.94e+06. What is the difference between the Aid flow (current US$) of France in 1996 and the Aid flow (current US$) of Japan in 2000?
Your answer should be very brief. -1.94e+07. What is the difference between the Aid flow (current US$) in Germany in 1996 and the Aid flow (current US$) in Italy in 2000?
Provide a short and direct response. 1.07e+07. What is the difference between the Aid flow (current US$) of Germany in 1996 and the Aid flow (current US$) of Japan in 2000?
Ensure brevity in your answer.  -1.46e+07. What is the difference between the Aid flow (current US$) of Italy in 1996 and the Aid flow (current US$) of Japan in 2000?
Keep it short and to the point. -3.04e+07. What is the difference between the Aid flow (current US$) of France in 1996 and the Aid flow (current US$) of Germany in 2001?
Offer a very short reply. -5.80e+05. What is the difference between the Aid flow (current US$) in France in 1996 and the Aid flow (current US$) in Italy in 2001?
Make the answer very short. 2.34e+06. What is the difference between the Aid flow (current US$) of France in 1996 and the Aid flow (current US$) of Japan in 2001?
Keep it short and to the point. -2.52e+07. What is the difference between the Aid flow (current US$) of Germany in 1996 and the Aid flow (current US$) of Italy in 2001?
Give a very brief answer. 7.06e+06. What is the difference between the Aid flow (current US$) in Germany in 1996 and the Aid flow (current US$) in Japan in 2001?
Ensure brevity in your answer.  -2.05e+07. What is the difference between the Aid flow (current US$) of Italy in 1996 and the Aid flow (current US$) of Japan in 2001?
Keep it short and to the point. -3.63e+07. What is the difference between the Aid flow (current US$) of France in 1997 and the Aid flow (current US$) of Germany in 1998?
Your answer should be compact. 4.01e+06. What is the difference between the Aid flow (current US$) of France in 1997 and the Aid flow (current US$) of Italy in 1998?
Your answer should be compact. 3.57e+06. What is the difference between the Aid flow (current US$) of France in 1997 and the Aid flow (current US$) of Japan in 1998?
Ensure brevity in your answer.  -3.91e+06. What is the difference between the Aid flow (current US$) in Germany in 1997 and the Aid flow (current US$) in Italy in 1998?
Your answer should be very brief. 1.11e+07. What is the difference between the Aid flow (current US$) in Germany in 1997 and the Aid flow (current US$) in Japan in 1998?
Provide a succinct answer. 3.63e+06. What is the difference between the Aid flow (current US$) in Italy in 1997 and the Aid flow (current US$) in Japan in 1998?
Your response must be concise. -1.55e+07. What is the difference between the Aid flow (current US$) in France in 1997 and the Aid flow (current US$) in Germany in 1999?
Provide a short and direct response. 1.86e+06. What is the difference between the Aid flow (current US$) of France in 1997 and the Aid flow (current US$) of Italy in 1999?
Keep it short and to the point. 4.78e+06. What is the difference between the Aid flow (current US$) of France in 1997 and the Aid flow (current US$) of Japan in 1999?
Make the answer very short. -8.72e+07. What is the difference between the Aid flow (current US$) in Germany in 1997 and the Aid flow (current US$) in Italy in 1999?
Offer a terse response. 1.23e+07. What is the difference between the Aid flow (current US$) in Germany in 1997 and the Aid flow (current US$) in Japan in 1999?
Your answer should be compact. -7.96e+07. What is the difference between the Aid flow (current US$) of Italy in 1997 and the Aid flow (current US$) of Japan in 1999?
Ensure brevity in your answer.  -9.88e+07. What is the difference between the Aid flow (current US$) of France in 1997 and the Aid flow (current US$) of Germany in 2000?
Give a very brief answer. 3.40e+06. What is the difference between the Aid flow (current US$) in France in 1997 and the Aid flow (current US$) in Italy in 2000?
Your answer should be compact. 6.94e+06. What is the difference between the Aid flow (current US$) in France in 1997 and the Aid flow (current US$) in Japan in 2000?
Provide a succinct answer. -1.84e+07. What is the difference between the Aid flow (current US$) in Germany in 1997 and the Aid flow (current US$) in Italy in 2000?
Your response must be concise. 1.45e+07. What is the difference between the Aid flow (current US$) in Germany in 1997 and the Aid flow (current US$) in Japan in 2000?
Offer a terse response. -1.08e+07. What is the difference between the Aid flow (current US$) in Italy in 1997 and the Aid flow (current US$) in Japan in 2000?
Your answer should be compact. -3.00e+07. What is the difference between the Aid flow (current US$) of France in 1997 and the Aid flow (current US$) of Germany in 2001?
Make the answer very short. 4.20e+05. What is the difference between the Aid flow (current US$) in France in 1997 and the Aid flow (current US$) in Italy in 2001?
Keep it short and to the point. 3.34e+06. What is the difference between the Aid flow (current US$) in France in 1997 and the Aid flow (current US$) in Japan in 2001?
Make the answer very short. -2.42e+07. What is the difference between the Aid flow (current US$) in Germany in 1997 and the Aid flow (current US$) in Italy in 2001?
Make the answer very short. 1.09e+07. What is the difference between the Aid flow (current US$) in Germany in 1997 and the Aid flow (current US$) in Japan in 2001?
Your answer should be compact. -1.67e+07. What is the difference between the Aid flow (current US$) in Italy in 1997 and the Aid flow (current US$) in Japan in 2001?
Give a very brief answer. -3.58e+07. What is the difference between the Aid flow (current US$) of France in 1998 and the Aid flow (current US$) of Germany in 1999?
Ensure brevity in your answer.  -9.80e+05. What is the difference between the Aid flow (current US$) in France in 1998 and the Aid flow (current US$) in Italy in 1999?
Your answer should be very brief. 1.94e+06. What is the difference between the Aid flow (current US$) in France in 1998 and the Aid flow (current US$) in Japan in 1999?
Provide a short and direct response. -9.00e+07. What is the difference between the Aid flow (current US$) of Germany in 1998 and the Aid flow (current US$) of Italy in 1999?
Provide a short and direct response. 7.70e+05. What is the difference between the Aid flow (current US$) of Germany in 1998 and the Aid flow (current US$) of Japan in 1999?
Ensure brevity in your answer.  -9.12e+07. What is the difference between the Aid flow (current US$) of Italy in 1998 and the Aid flow (current US$) of Japan in 1999?
Ensure brevity in your answer.  -9.07e+07. What is the difference between the Aid flow (current US$) in France in 1998 and the Aid flow (current US$) in Germany in 2000?
Offer a very short reply. 5.60e+05. What is the difference between the Aid flow (current US$) in France in 1998 and the Aid flow (current US$) in Italy in 2000?
Make the answer very short. 4.10e+06. What is the difference between the Aid flow (current US$) in France in 1998 and the Aid flow (current US$) in Japan in 2000?
Make the answer very short. -2.12e+07. What is the difference between the Aid flow (current US$) in Germany in 1998 and the Aid flow (current US$) in Italy in 2000?
Provide a succinct answer. 2.93e+06. What is the difference between the Aid flow (current US$) in Germany in 1998 and the Aid flow (current US$) in Japan in 2000?
Make the answer very short. -2.24e+07. What is the difference between the Aid flow (current US$) in Italy in 1998 and the Aid flow (current US$) in Japan in 2000?
Your answer should be compact. -2.19e+07. What is the difference between the Aid flow (current US$) in France in 1998 and the Aid flow (current US$) in Germany in 2001?
Make the answer very short. -2.42e+06. What is the difference between the Aid flow (current US$) of France in 1998 and the Aid flow (current US$) of Italy in 2001?
Your answer should be compact. 5.00e+05. What is the difference between the Aid flow (current US$) of France in 1998 and the Aid flow (current US$) of Japan in 2001?
Your response must be concise. -2.70e+07. What is the difference between the Aid flow (current US$) in Germany in 1998 and the Aid flow (current US$) in Italy in 2001?
Offer a terse response. -6.70e+05. What is the difference between the Aid flow (current US$) in Germany in 1998 and the Aid flow (current US$) in Japan in 2001?
Your response must be concise. -2.82e+07. What is the difference between the Aid flow (current US$) in Italy in 1998 and the Aid flow (current US$) in Japan in 2001?
Your answer should be compact. -2.78e+07. What is the difference between the Aid flow (current US$) in France in 1999 and the Aid flow (current US$) in Germany in 2000?
Provide a succinct answer. 4.66e+06. What is the difference between the Aid flow (current US$) in France in 1999 and the Aid flow (current US$) in Italy in 2000?
Your answer should be compact. 8.20e+06. What is the difference between the Aid flow (current US$) of France in 1999 and the Aid flow (current US$) of Japan in 2000?
Offer a terse response. -1.71e+07. What is the difference between the Aid flow (current US$) of Germany in 1999 and the Aid flow (current US$) of Italy in 2000?
Your answer should be compact. 5.08e+06. What is the difference between the Aid flow (current US$) in Germany in 1999 and the Aid flow (current US$) in Japan in 2000?
Keep it short and to the point. -2.02e+07. What is the difference between the Aid flow (current US$) of Italy in 1999 and the Aid flow (current US$) of Japan in 2000?
Provide a short and direct response. -2.31e+07. What is the difference between the Aid flow (current US$) of France in 1999 and the Aid flow (current US$) of Germany in 2001?
Your answer should be very brief. 1.68e+06. What is the difference between the Aid flow (current US$) of France in 1999 and the Aid flow (current US$) of Italy in 2001?
Offer a very short reply. 4.60e+06. What is the difference between the Aid flow (current US$) of France in 1999 and the Aid flow (current US$) of Japan in 2001?
Provide a short and direct response. -2.29e+07. What is the difference between the Aid flow (current US$) of Germany in 1999 and the Aid flow (current US$) of Italy in 2001?
Give a very brief answer. 1.48e+06. What is the difference between the Aid flow (current US$) in Germany in 1999 and the Aid flow (current US$) in Japan in 2001?
Your response must be concise. -2.61e+07. What is the difference between the Aid flow (current US$) of Italy in 1999 and the Aid flow (current US$) of Japan in 2001?
Make the answer very short. -2.90e+07. What is the difference between the Aid flow (current US$) in France in 2000 and the Aid flow (current US$) in Germany in 2001?
Keep it short and to the point. -5.92e+06. What is the difference between the Aid flow (current US$) in France in 2000 and the Aid flow (current US$) in Japan in 2001?
Ensure brevity in your answer.  -3.05e+07. What is the difference between the Aid flow (current US$) in Germany in 2000 and the Aid flow (current US$) in Japan in 2001?
Keep it short and to the point. -2.76e+07. What is the difference between the Aid flow (current US$) in Italy in 2000 and the Aid flow (current US$) in Japan in 2001?
Offer a terse response. -3.11e+07. What is the average Aid flow (current US$) in France per year?
Make the answer very short. 1.36e+07. What is the average Aid flow (current US$) in Germany per year?
Offer a terse response. 1.23e+07. What is the average Aid flow (current US$) of Italy per year?
Your response must be concise. 4.11e+06. What is the average Aid flow (current US$) in Japan per year?
Make the answer very short. 3.66e+07. In the year 1993, what is the difference between the Aid flow (current US$) of France and Aid flow (current US$) of Germany?
Provide a short and direct response. 2.96e+07. In the year 1993, what is the difference between the Aid flow (current US$) in France and Aid flow (current US$) in Italy?
Keep it short and to the point. 3.57e+07. In the year 1993, what is the difference between the Aid flow (current US$) in France and Aid flow (current US$) in Japan?
Ensure brevity in your answer.  2.68e+07. In the year 1993, what is the difference between the Aid flow (current US$) in Germany and Aid flow (current US$) in Italy?
Offer a very short reply. 6.03e+06. In the year 1993, what is the difference between the Aid flow (current US$) of Germany and Aid flow (current US$) of Japan?
Your answer should be compact. -2.83e+06. In the year 1993, what is the difference between the Aid flow (current US$) in Italy and Aid flow (current US$) in Japan?
Make the answer very short. -8.86e+06. In the year 1994, what is the difference between the Aid flow (current US$) in France and Aid flow (current US$) in Germany?
Offer a very short reply. -1.53e+06. In the year 1994, what is the difference between the Aid flow (current US$) of France and Aid flow (current US$) of Italy?
Your answer should be very brief. 1.31e+07. In the year 1994, what is the difference between the Aid flow (current US$) of France and Aid flow (current US$) of Japan?
Offer a terse response. -1.20e+05. In the year 1994, what is the difference between the Aid flow (current US$) of Germany and Aid flow (current US$) of Italy?
Make the answer very short. 1.46e+07. In the year 1994, what is the difference between the Aid flow (current US$) in Germany and Aid flow (current US$) in Japan?
Give a very brief answer. 1.41e+06. In the year 1994, what is the difference between the Aid flow (current US$) of Italy and Aid flow (current US$) of Japan?
Give a very brief answer. -1.32e+07. In the year 1995, what is the difference between the Aid flow (current US$) in France and Aid flow (current US$) in Germany?
Offer a very short reply. 5.16e+06. In the year 1995, what is the difference between the Aid flow (current US$) of France and Aid flow (current US$) of Italy?
Keep it short and to the point. 1.40e+07. In the year 1995, what is the difference between the Aid flow (current US$) in France and Aid flow (current US$) in Japan?
Offer a very short reply. -1.06e+07. In the year 1995, what is the difference between the Aid flow (current US$) in Germany and Aid flow (current US$) in Italy?
Make the answer very short. 8.81e+06. In the year 1995, what is the difference between the Aid flow (current US$) of Germany and Aid flow (current US$) of Japan?
Make the answer very short. -1.57e+07. In the year 1995, what is the difference between the Aid flow (current US$) of Italy and Aid flow (current US$) of Japan?
Give a very brief answer. -2.45e+07. In the year 1996, what is the difference between the Aid flow (current US$) in France and Aid flow (current US$) in Germany?
Make the answer very short. -4.72e+06. In the year 1996, what is the difference between the Aid flow (current US$) in France and Aid flow (current US$) in Italy?
Keep it short and to the point. 1.11e+07. In the year 1996, what is the difference between the Aid flow (current US$) of France and Aid flow (current US$) of Japan?
Your response must be concise. -1.38e+07. In the year 1996, what is the difference between the Aid flow (current US$) of Germany and Aid flow (current US$) of Italy?
Give a very brief answer. 1.58e+07. In the year 1996, what is the difference between the Aid flow (current US$) of Germany and Aid flow (current US$) of Japan?
Offer a very short reply. -9.03e+06. In the year 1996, what is the difference between the Aid flow (current US$) of Italy and Aid flow (current US$) of Japan?
Offer a very short reply. -2.48e+07. In the year 1997, what is the difference between the Aid flow (current US$) in France and Aid flow (current US$) in Germany?
Make the answer very short. -7.54e+06. In the year 1997, what is the difference between the Aid flow (current US$) in France and Aid flow (current US$) in Italy?
Provide a succinct answer. 1.16e+07. In the year 1997, what is the difference between the Aid flow (current US$) in France and Aid flow (current US$) in Japan?
Offer a terse response. -5.71e+07. In the year 1997, what is the difference between the Aid flow (current US$) in Germany and Aid flow (current US$) in Italy?
Offer a very short reply. 1.92e+07. In the year 1997, what is the difference between the Aid flow (current US$) of Germany and Aid flow (current US$) of Japan?
Your answer should be very brief. -4.95e+07. In the year 1997, what is the difference between the Aid flow (current US$) of Italy and Aid flow (current US$) of Japan?
Your answer should be compact. -6.87e+07. In the year 1998, what is the difference between the Aid flow (current US$) of France and Aid flow (current US$) of Germany?
Offer a very short reply. 1.17e+06. In the year 1998, what is the difference between the Aid flow (current US$) in France and Aid flow (current US$) in Italy?
Your response must be concise. 7.30e+05. In the year 1998, what is the difference between the Aid flow (current US$) in France and Aid flow (current US$) in Japan?
Offer a terse response. -6.75e+06. In the year 1998, what is the difference between the Aid flow (current US$) of Germany and Aid flow (current US$) of Italy?
Ensure brevity in your answer.  -4.40e+05. In the year 1998, what is the difference between the Aid flow (current US$) in Germany and Aid flow (current US$) in Japan?
Offer a terse response. -7.92e+06. In the year 1998, what is the difference between the Aid flow (current US$) of Italy and Aid flow (current US$) of Japan?
Offer a terse response. -7.48e+06. In the year 1999, what is the difference between the Aid flow (current US$) of France and Aid flow (current US$) of Germany?
Your answer should be very brief. 3.12e+06. In the year 1999, what is the difference between the Aid flow (current US$) in France and Aid flow (current US$) in Italy?
Provide a succinct answer. 6.04e+06. In the year 1999, what is the difference between the Aid flow (current US$) in France and Aid flow (current US$) in Japan?
Provide a short and direct response. -8.59e+07. In the year 1999, what is the difference between the Aid flow (current US$) in Germany and Aid flow (current US$) in Italy?
Offer a very short reply. 2.92e+06. In the year 1999, what is the difference between the Aid flow (current US$) in Germany and Aid flow (current US$) in Japan?
Your response must be concise. -8.90e+07. In the year 1999, what is the difference between the Aid flow (current US$) in Italy and Aid flow (current US$) in Japan?
Your answer should be compact. -9.20e+07. In the year 2000, what is the difference between the Aid flow (current US$) of France and Aid flow (current US$) of Germany?
Offer a terse response. -2.94e+06. In the year 2000, what is the difference between the Aid flow (current US$) in France and Aid flow (current US$) in Japan?
Your answer should be very brief. -2.47e+07. In the year 2000, what is the difference between the Aid flow (current US$) in Germany and Aid flow (current US$) in Italy?
Your answer should be compact. 3.54e+06. In the year 2000, what is the difference between the Aid flow (current US$) in Germany and Aid flow (current US$) in Japan?
Ensure brevity in your answer.  -2.18e+07. In the year 2000, what is the difference between the Aid flow (current US$) of Italy and Aid flow (current US$) of Japan?
Offer a very short reply. -2.53e+07. In the year 2001, what is the difference between the Aid flow (current US$) of France and Aid flow (current US$) of Germany?
Keep it short and to the point. -1.08e+07. In the year 2001, what is the difference between the Aid flow (current US$) of France and Aid flow (current US$) of Italy?
Ensure brevity in your answer.  -7.88e+06. In the year 2001, what is the difference between the Aid flow (current US$) of France and Aid flow (current US$) of Japan?
Give a very brief answer. -3.54e+07. In the year 2001, what is the difference between the Aid flow (current US$) in Germany and Aid flow (current US$) in Italy?
Give a very brief answer. 2.92e+06. In the year 2001, what is the difference between the Aid flow (current US$) in Germany and Aid flow (current US$) in Japan?
Ensure brevity in your answer.  -2.46e+07. In the year 2001, what is the difference between the Aid flow (current US$) in Italy and Aid flow (current US$) in Japan?
Ensure brevity in your answer.  -2.75e+07. What is the ratio of the Aid flow (current US$) in France in 1993 to that in 1994?
Ensure brevity in your answer.  2.57. What is the ratio of the Aid flow (current US$) of Germany in 1993 to that in 1994?
Provide a short and direct response. 0.43. What is the ratio of the Aid flow (current US$) in Italy in 1993 to that in 1994?
Your answer should be very brief. 0.67. What is the ratio of the Aid flow (current US$) of Japan in 1993 to that in 1994?
Your answer should be very brief. 0.67. What is the ratio of the Aid flow (current US$) in France in 1993 to that in 1995?
Provide a short and direct response. 2.5. What is the ratio of the Aid flow (current US$) of Germany in 1993 to that in 1995?
Offer a very short reply. 0.72. What is the ratio of the Aid flow (current US$) of Italy in 1993 to that in 1995?
Offer a terse response. 1.16. What is the ratio of the Aid flow (current US$) of Japan in 1993 to that in 1995?
Offer a very short reply. 0.38. What is the ratio of the Aid flow (current US$) in France in 1993 to that in 1996?
Offer a terse response. 3.08. What is the ratio of the Aid flow (current US$) in Germany in 1993 to that in 1996?
Your answer should be compact. 0.41. What is the ratio of the Aid flow (current US$) of Italy in 1993 to that in 1996?
Provide a succinct answer. 0.96. What is the ratio of the Aid flow (current US$) in Japan in 1993 to that in 1996?
Keep it short and to the point. 0.37. What is the ratio of the Aid flow (current US$) in France in 1993 to that in 1997?
Give a very brief answer. 2.84. What is the ratio of the Aid flow (current US$) in Germany in 1993 to that in 1997?
Keep it short and to the point. 0.33. What is the ratio of the Aid flow (current US$) in Italy in 1993 to that in 1997?
Your response must be concise. 0.58. What is the ratio of the Aid flow (current US$) of Japan in 1993 to that in 1997?
Your answer should be compact. 0.14. What is the ratio of the Aid flow (current US$) of France in 1993 to that in 1998?
Offer a very short reply. 3.64. What is the ratio of the Aid flow (current US$) in Germany in 1993 to that in 1998?
Make the answer very short. 0.76. What is the ratio of the Aid flow (current US$) in Italy in 1993 to that in 1998?
Provide a succinct answer. 0.08. What is the ratio of the Aid flow (current US$) of Japan in 1993 to that in 1998?
Your answer should be compact. 0.57. What is the ratio of the Aid flow (current US$) of France in 1993 to that in 1999?
Your answer should be compact. 2.58. What is the ratio of the Aid flow (current US$) in Germany in 1993 to that in 1999?
Your response must be concise. 0.61. What is the ratio of the Aid flow (current US$) of Italy in 1993 to that in 1999?
Keep it short and to the point. 0.09. What is the ratio of the Aid flow (current US$) of Japan in 1993 to that in 1999?
Ensure brevity in your answer.  0.1. What is the ratio of the Aid flow (current US$) of France in 1993 to that in 2000?
Offer a terse response. 5.61. What is the ratio of the Aid flow (current US$) in Germany in 1993 to that in 2000?
Give a very brief answer. 0.71. What is the ratio of the Aid flow (current US$) in Italy in 1993 to that in 2000?
Keep it short and to the point. 0.12. What is the ratio of the Aid flow (current US$) of Japan in 1993 to that in 2000?
Your answer should be very brief. 0.31. What is the ratio of the Aid flow (current US$) in France in 1993 to that in 2001?
Your response must be concise. 22.6. What is the ratio of the Aid flow (current US$) of Germany in 1993 to that in 2001?
Your answer should be compact. 0.54. What is the ratio of the Aid flow (current US$) in Italy in 1993 to that in 2001?
Your answer should be very brief. 0.07. What is the ratio of the Aid flow (current US$) in Japan in 1993 to that in 2001?
Make the answer very short. 0.26. What is the ratio of the Aid flow (current US$) in France in 1994 to that in 1995?
Offer a terse response. 0.97. What is the ratio of the Aid flow (current US$) in Italy in 1994 to that in 1995?
Give a very brief answer. 1.74. What is the ratio of the Aid flow (current US$) in Japan in 1994 to that in 1995?
Keep it short and to the point. 0.57. What is the ratio of the Aid flow (current US$) of France in 1994 to that in 1996?
Ensure brevity in your answer.  1.2. What is the ratio of the Aid flow (current US$) of Germany in 1994 to that in 1996?
Offer a very short reply. 0.95. What is the ratio of the Aid flow (current US$) in Italy in 1994 to that in 1996?
Your answer should be compact. 1.43. What is the ratio of the Aid flow (current US$) of Japan in 1994 to that in 1996?
Provide a succinct answer. 0.56. What is the ratio of the Aid flow (current US$) of France in 1994 to that in 1997?
Make the answer very short. 1.1. What is the ratio of the Aid flow (current US$) of Germany in 1994 to that in 1997?
Give a very brief answer. 0.77. What is the ratio of the Aid flow (current US$) of Italy in 1994 to that in 1997?
Keep it short and to the point. 0.87. What is the ratio of the Aid flow (current US$) in Japan in 1994 to that in 1997?
Offer a very short reply. 0.2. What is the ratio of the Aid flow (current US$) in France in 1994 to that in 1998?
Your answer should be very brief. 1.42. What is the ratio of the Aid flow (current US$) of Germany in 1994 to that in 1998?
Your answer should be very brief. 1.78. What is the ratio of the Aid flow (current US$) of Italy in 1994 to that in 1998?
Your answer should be compact. 0.11. What is the ratio of the Aid flow (current US$) in Japan in 1994 to that in 1998?
Your answer should be compact. 0.85. What is the ratio of the Aid flow (current US$) of France in 1994 to that in 1999?
Your response must be concise. 1.01. What is the ratio of the Aid flow (current US$) of Germany in 1994 to that in 1999?
Give a very brief answer. 1.43. What is the ratio of the Aid flow (current US$) of Italy in 1994 to that in 1999?
Your answer should be compact. 0.13. What is the ratio of the Aid flow (current US$) in Japan in 1994 to that in 1999?
Provide a succinct answer. 0.14. What is the ratio of the Aid flow (current US$) of France in 1994 to that in 2000?
Provide a short and direct response. 2.18. What is the ratio of the Aid flow (current US$) of Germany in 1994 to that in 2000?
Provide a succinct answer. 1.66. What is the ratio of the Aid flow (current US$) of Italy in 1994 to that in 2000?
Your answer should be very brief. 0.18. What is the ratio of the Aid flow (current US$) of Japan in 1994 to that in 2000?
Offer a very short reply. 0.46. What is the ratio of the Aid flow (current US$) of France in 1994 to that in 2001?
Keep it short and to the point. 8.8. What is the ratio of the Aid flow (current US$) in Germany in 1994 to that in 2001?
Ensure brevity in your answer.  1.27. What is the ratio of the Aid flow (current US$) in Italy in 1994 to that in 2001?
Keep it short and to the point. 0.11. What is the ratio of the Aid flow (current US$) of Japan in 1994 to that in 2001?
Your answer should be compact. 0.39. What is the ratio of the Aid flow (current US$) of France in 1995 to that in 1996?
Provide a succinct answer. 1.23. What is the ratio of the Aid flow (current US$) in Germany in 1995 to that in 1996?
Your answer should be very brief. 0.57. What is the ratio of the Aid flow (current US$) in Italy in 1995 to that in 1996?
Provide a short and direct response. 0.82. What is the ratio of the Aid flow (current US$) in Japan in 1995 to that in 1996?
Ensure brevity in your answer.  0.98. What is the ratio of the Aid flow (current US$) of France in 1995 to that in 1997?
Make the answer very short. 1.14. What is the ratio of the Aid flow (current US$) in Germany in 1995 to that in 1997?
Offer a terse response. 0.46. What is the ratio of the Aid flow (current US$) of Japan in 1995 to that in 1997?
Provide a short and direct response. 0.36. What is the ratio of the Aid flow (current US$) of France in 1995 to that in 1998?
Ensure brevity in your answer.  1.46. What is the ratio of the Aid flow (current US$) in Germany in 1995 to that in 1998?
Provide a short and direct response. 1.07. What is the ratio of the Aid flow (current US$) of Italy in 1995 to that in 1998?
Offer a terse response. 0.07. What is the ratio of the Aid flow (current US$) in Japan in 1995 to that in 1998?
Provide a succinct answer. 1.5. What is the ratio of the Aid flow (current US$) in France in 1995 to that in 1999?
Your answer should be compact. 1.03. What is the ratio of the Aid flow (current US$) of Germany in 1995 to that in 1999?
Keep it short and to the point. 0.86. What is the ratio of the Aid flow (current US$) of Italy in 1995 to that in 1999?
Offer a very short reply. 0.08. What is the ratio of the Aid flow (current US$) in Japan in 1995 to that in 1999?
Your answer should be compact. 0.25. What is the ratio of the Aid flow (current US$) of France in 1995 to that in 2000?
Offer a very short reply. 2.25. What is the ratio of the Aid flow (current US$) in Italy in 1995 to that in 2000?
Ensure brevity in your answer.  0.1. What is the ratio of the Aid flow (current US$) of Japan in 1995 to that in 2000?
Provide a succinct answer. 0.81. What is the ratio of the Aid flow (current US$) of France in 1995 to that in 2001?
Provide a succinct answer. 9.06. What is the ratio of the Aid flow (current US$) in Germany in 1995 to that in 2001?
Make the answer very short. 0.76. What is the ratio of the Aid flow (current US$) in Italy in 1995 to that in 2001?
Offer a very short reply. 0.06. What is the ratio of the Aid flow (current US$) in Japan in 1995 to that in 2001?
Your response must be concise. 0.68. What is the ratio of the Aid flow (current US$) of France in 1996 to that in 1997?
Your response must be concise. 0.92. What is the ratio of the Aid flow (current US$) of Germany in 1996 to that in 1997?
Offer a very short reply. 0.81. What is the ratio of the Aid flow (current US$) of Italy in 1996 to that in 1997?
Your answer should be very brief. 0.61. What is the ratio of the Aid flow (current US$) in Japan in 1996 to that in 1997?
Offer a terse response. 0.37. What is the ratio of the Aid flow (current US$) in France in 1996 to that in 1998?
Ensure brevity in your answer.  1.18. What is the ratio of the Aid flow (current US$) in Germany in 1996 to that in 1998?
Your answer should be very brief. 1.88. What is the ratio of the Aid flow (current US$) of Italy in 1996 to that in 1998?
Your response must be concise. 0.08. What is the ratio of the Aid flow (current US$) in Japan in 1996 to that in 1998?
Offer a terse response. 1.53. What is the ratio of the Aid flow (current US$) of France in 1996 to that in 1999?
Offer a terse response. 0.84. What is the ratio of the Aid flow (current US$) of Germany in 1996 to that in 1999?
Offer a very short reply. 1.51. What is the ratio of the Aid flow (current US$) in Italy in 1996 to that in 1999?
Provide a succinct answer. 0.09. What is the ratio of the Aid flow (current US$) of Japan in 1996 to that in 1999?
Your answer should be very brief. 0.26. What is the ratio of the Aid flow (current US$) in France in 1996 to that in 2000?
Your answer should be compact. 1.82. What is the ratio of the Aid flow (current US$) in Germany in 1996 to that in 2000?
Provide a succinct answer. 1.75. What is the ratio of the Aid flow (current US$) of Italy in 1996 to that in 2000?
Make the answer very short. 0.13. What is the ratio of the Aid flow (current US$) in Japan in 1996 to that in 2000?
Your answer should be compact. 0.82. What is the ratio of the Aid flow (current US$) of France in 1996 to that in 2001?
Offer a very short reply. 7.35. What is the ratio of the Aid flow (current US$) in Germany in 1996 to that in 2001?
Make the answer very short. 1.33. What is the ratio of the Aid flow (current US$) in Italy in 1996 to that in 2001?
Keep it short and to the point. 0.08. What is the ratio of the Aid flow (current US$) of Japan in 1996 to that in 2001?
Offer a terse response. 0.69. What is the ratio of the Aid flow (current US$) of France in 1997 to that in 1998?
Offer a very short reply. 1.28. What is the ratio of the Aid flow (current US$) of Germany in 1997 to that in 1998?
Your answer should be very brief. 2.31. What is the ratio of the Aid flow (current US$) of Italy in 1997 to that in 1998?
Give a very brief answer. 0.13. What is the ratio of the Aid flow (current US$) of Japan in 1997 to that in 1998?
Provide a short and direct response. 4.17. What is the ratio of the Aid flow (current US$) of France in 1997 to that in 1999?
Offer a terse response. 0.91. What is the ratio of the Aid flow (current US$) in Germany in 1997 to that in 1999?
Provide a short and direct response. 1.86. What is the ratio of the Aid flow (current US$) in Italy in 1997 to that in 1999?
Keep it short and to the point. 0.15. What is the ratio of the Aid flow (current US$) of Japan in 1997 to that in 1999?
Make the answer very short. 0.7. What is the ratio of the Aid flow (current US$) in France in 1997 to that in 2000?
Provide a short and direct response. 1.98. What is the ratio of the Aid flow (current US$) of Germany in 1997 to that in 2000?
Provide a short and direct response. 2.16. What is the ratio of the Aid flow (current US$) in Italy in 1997 to that in 2000?
Ensure brevity in your answer.  0.21. What is the ratio of the Aid flow (current US$) in Japan in 1997 to that in 2000?
Offer a very short reply. 2.24. What is the ratio of the Aid flow (current US$) of France in 1997 to that in 2001?
Your answer should be compact. 7.97. What is the ratio of the Aid flow (current US$) in Germany in 1997 to that in 2001?
Provide a short and direct response. 1.64. What is the ratio of the Aid flow (current US$) in Italy in 1997 to that in 2001?
Provide a short and direct response. 0.13. What is the ratio of the Aid flow (current US$) in Japan in 1997 to that in 2001?
Offer a terse response. 1.89. What is the ratio of the Aid flow (current US$) in France in 1998 to that in 1999?
Provide a succinct answer. 0.71. What is the ratio of the Aid flow (current US$) in Germany in 1998 to that in 1999?
Keep it short and to the point. 0.8. What is the ratio of the Aid flow (current US$) of Italy in 1998 to that in 1999?
Provide a succinct answer. 1.15. What is the ratio of the Aid flow (current US$) in Japan in 1998 to that in 1999?
Make the answer very short. 0.17. What is the ratio of the Aid flow (current US$) in France in 1998 to that in 2000?
Provide a short and direct response. 1.54. What is the ratio of the Aid flow (current US$) in Germany in 1998 to that in 2000?
Offer a terse response. 0.94. What is the ratio of the Aid flow (current US$) in Italy in 1998 to that in 2000?
Make the answer very short. 1.57. What is the ratio of the Aid flow (current US$) in Japan in 1998 to that in 2000?
Your response must be concise. 0.54. What is the ratio of the Aid flow (current US$) of France in 1998 to that in 2001?
Keep it short and to the point. 6.21. What is the ratio of the Aid flow (current US$) of Germany in 1998 to that in 2001?
Ensure brevity in your answer.  0.71. What is the ratio of the Aid flow (current US$) in Italy in 1998 to that in 2001?
Provide a succinct answer. 0.98. What is the ratio of the Aid flow (current US$) of Japan in 1998 to that in 2001?
Your answer should be very brief. 0.45. What is the ratio of the Aid flow (current US$) in France in 1999 to that in 2000?
Provide a short and direct response. 2.17. What is the ratio of the Aid flow (current US$) in Germany in 1999 to that in 2000?
Ensure brevity in your answer.  1.16. What is the ratio of the Aid flow (current US$) of Italy in 1999 to that in 2000?
Give a very brief answer. 1.37. What is the ratio of the Aid flow (current US$) in Japan in 1999 to that in 2000?
Ensure brevity in your answer.  3.21. What is the ratio of the Aid flow (current US$) in France in 1999 to that in 2001?
Your answer should be very brief. 8.75. What is the ratio of the Aid flow (current US$) in Germany in 1999 to that in 2001?
Offer a terse response. 0.88. What is the ratio of the Aid flow (current US$) of Italy in 1999 to that in 2001?
Your answer should be compact. 0.85. What is the ratio of the Aid flow (current US$) in Japan in 1999 to that in 2001?
Keep it short and to the point. 2.7. What is the ratio of the Aid flow (current US$) in France in 2000 to that in 2001?
Your answer should be very brief. 4.03. What is the ratio of the Aid flow (current US$) in Germany in 2000 to that in 2001?
Provide a short and direct response. 0.76. What is the ratio of the Aid flow (current US$) of Italy in 2000 to that in 2001?
Your answer should be compact. 0.62. What is the ratio of the Aid flow (current US$) in Japan in 2000 to that in 2001?
Your response must be concise. 0.84. What is the difference between the highest and the second highest Aid flow (current US$) of France?
Provide a short and direct response. 2.18e+07. What is the difference between the highest and the second highest Aid flow (current US$) in Germany?
Keep it short and to the point. 3.82e+06. What is the difference between the highest and the second highest Aid flow (current US$) in Italy?
Offer a very short reply. 2.30e+05. What is the difference between the highest and the second highest Aid flow (current US$) in Japan?
Make the answer very short. 3.01e+07. What is the difference between the highest and the lowest Aid flow (current US$) of France?
Offer a very short reply. 3.48e+07. What is the difference between the highest and the lowest Aid flow (current US$) in Germany?
Keep it short and to the point. 1.36e+07. What is the difference between the highest and the lowest Aid flow (current US$) of Italy?
Make the answer very short. 8.88e+06. What is the difference between the highest and the lowest Aid flow (current US$) of Japan?
Provide a succinct answer. 9.04e+07. 